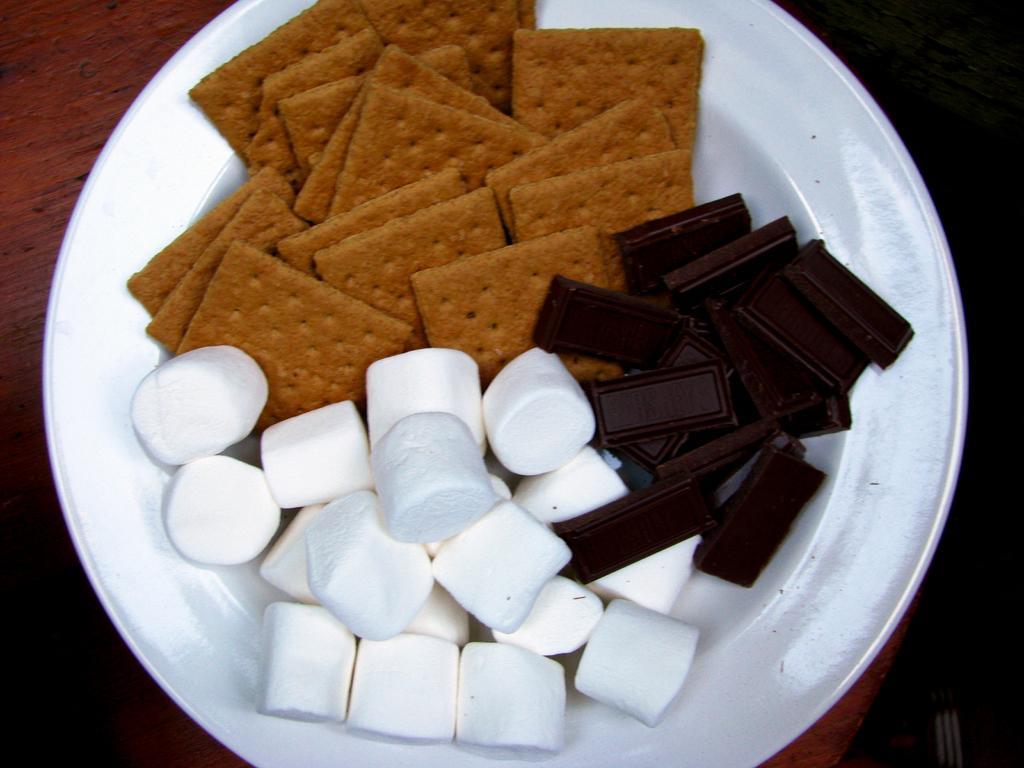In one or two sentences, can you explain what this image depicts? In this image we can see biscuits, dark chocolate, marshmallow, in the plate, there is the wooden table. 